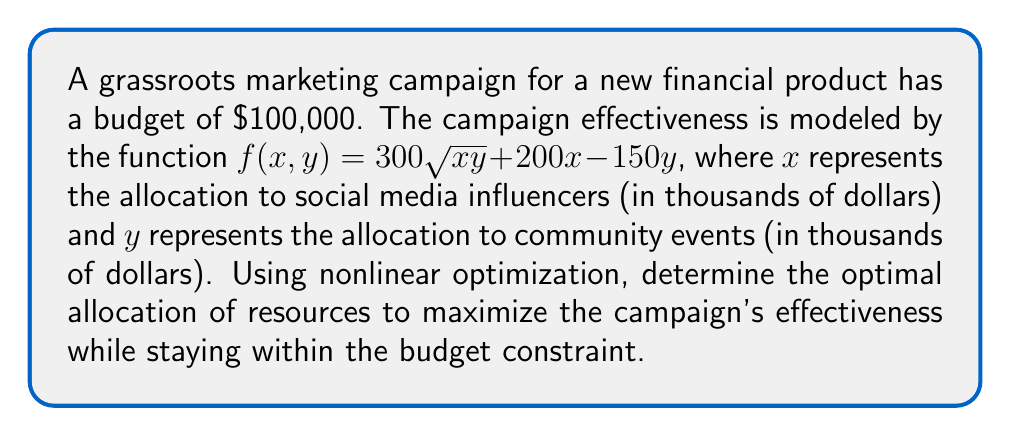Show me your answer to this math problem. To solve this nonlinear optimization problem, we'll use the method of Lagrange multipliers:

1) First, we set up the Lagrangian function:
   $$L(x, y, \lambda) = 300\sqrt{xy} + 200x - 150y + \lambda(100 - x - y)$$

2) Now, we take partial derivatives and set them equal to zero:
   $$\frac{\partial L}{\partial x} = \frac{150y}{\sqrt{xy}} + 200 - \lambda = 0$$
   $$\frac{\partial L}{\partial y} = \frac{150x}{\sqrt{xy}} - 150 - \lambda = 0$$
   $$\frac{\partial L}{\partial \lambda} = 100 - x - y = 0$$

3) From the first two equations:
   $$\frac{150y}{\sqrt{xy}} + 200 = \frac{150x}{\sqrt{xy}} - 150$$
   $$\frac{150y}{\sqrt{xy}} + 350 = \frac{150x}{\sqrt{xy}}$$
   $$y + \frac{7\sqrt{xy}}{3} = x$$

4) Substituting this into the budget constraint:
   $$100 = x + y = (y + \frac{7\sqrt{xy}}{3}) + y = 2y + \frac{7\sqrt{xy}}{3}$$

5) Solving this equation:
   $$300 = 6y + 7\sqrt{xy}$$
   $$(\frac{300 - 6y}{7})^2 = xy$$
   $$x = \frac{(300 - 6y)^2}{49y}$$

6) Substituting back into the budget constraint:
   $$100 = \frac{(300 - 6y)^2}{49y} + y$$

7) Solving this equation numerically (as it's a 4th degree equation), we get:
   $$y \approx 37.5$$

8) And consequently:
   $$x \approx 62.5$$

Therefore, the optimal allocation is approximately $62,500 to social media influencers and $37,500 to community events.
Answer: $62,500 to influencers, $37,500 to events 